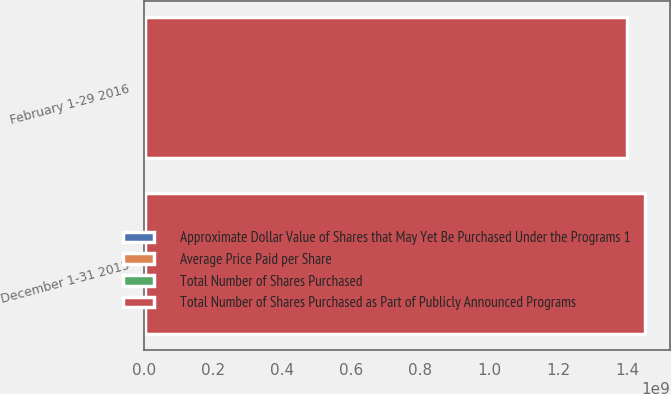<chart> <loc_0><loc_0><loc_500><loc_500><stacked_bar_chart><ecel><fcel>December 1-31 2015<fcel>February 1-29 2016<nl><fcel>Approximate Dollar Value of Shares that May Yet Be Purchased Under the Programs 1<fcel>1.86508e+06<fcel>1.0989e+06<nl><fcel>Average Price Paid per Share<fcel>57.21<fcel>44.71<nl><fcel>Total Number of Shares Purchased<fcel>1.86508e+06<fcel>1.0989e+06<nl><fcel>Total Number of Shares Purchased as Part of Publicly Announced Programs<fcel>1.44715e+09<fcel>1.39802e+09<nl></chart> 